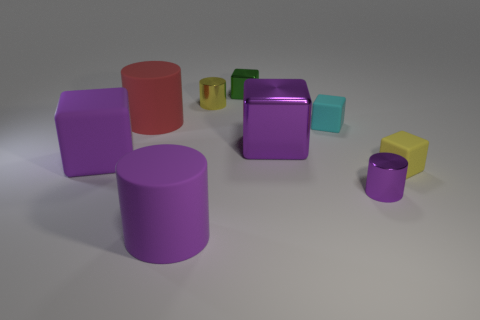Are there any other things that are the same shape as the green object?
Your answer should be compact. Yes. There is a purple metallic cylinder; how many cylinders are in front of it?
Provide a succinct answer. 1. Are there the same number of large shiny objects that are behind the tiny yellow metal cylinder and small brown blocks?
Keep it short and to the point. Yes. Is the material of the red cylinder the same as the green block?
Your answer should be very brief. No. How big is the cylinder that is both in front of the small cyan object and to the left of the tiny green block?
Your answer should be compact. Large. How many yellow metal things are the same size as the yellow metallic cylinder?
Keep it short and to the point. 0. There is a cube that is behind the small cylinder that is behind the tiny purple thing; how big is it?
Your response must be concise. Small. There is a purple metal object behind the tiny purple cylinder; is its shape the same as the yellow object on the left side of the tiny green shiny thing?
Make the answer very short. No. What is the color of the large object that is both behind the purple matte cube and to the left of the green block?
Provide a succinct answer. Red. Are there any big shiny cubes that have the same color as the big matte block?
Offer a terse response. Yes. 